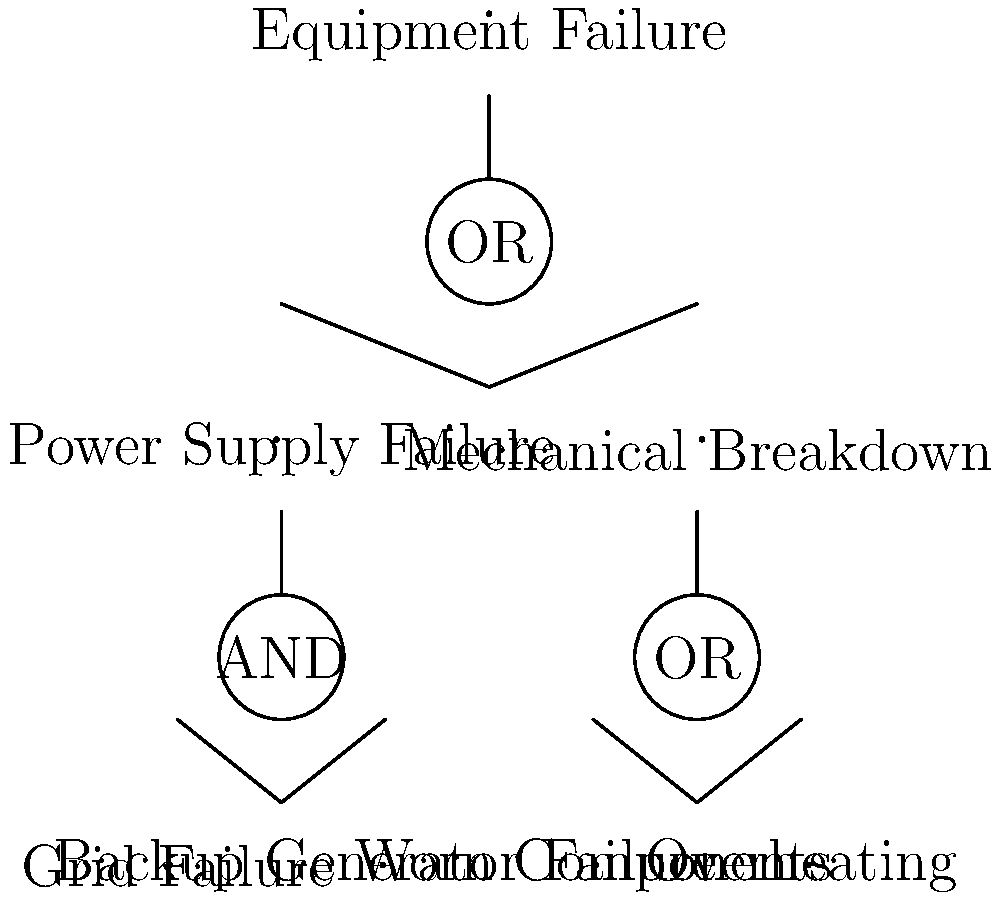Given the fault tree diagram for equipment failure in a construction project, what is the minimum number of basic events that need to occur simultaneously to cause the top event (Equipment Failure)? To determine the minimum number of basic events that need to occur simultaneously to cause Equipment Failure, we need to analyze the fault tree diagram from bottom to top:

1. The diagram shows two main branches: Power Supply Failure and Mechanical Breakdown.

2. For Power Supply Failure:
   - It's connected to an AND gate, meaning both inputs must occur.
   - The inputs are Grid Failure AND Backup Generator Failure.
   - This requires 2 simultaneous basic events.

3. For Mechanical Breakdown:
   - It's connected to an OR gate, meaning either input can cause it.
   - The inputs are Worn Components OR Overheating.
   - This requires only 1 basic event.

4. The top event (Equipment Failure) is connected to an OR gate with Power Supply Failure and Mechanical Breakdown as inputs.

5. Since we're looking for the minimum number of simultaneous events, we choose the branch with fewer required events, which is Mechanical Breakdown.

Therefore, the minimum number of basic events that need to occur simultaneously to cause Equipment Failure is 1, which could be either Worn Components or Overheating.
Answer: 1 